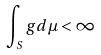Convert formula to latex. <formula><loc_0><loc_0><loc_500><loc_500>\int _ { S } g d \mu < \infty</formula> 